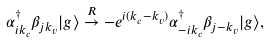<formula> <loc_0><loc_0><loc_500><loc_500>\alpha ^ { \dag } _ { i k _ { c } } \beta _ { j k _ { v } } | g \rangle \stackrel { R } { \to } - e ^ { i ( k _ { c } - k _ { v } ) } \alpha ^ { \dag } _ { - i k _ { c } } \beta _ { j - k _ { v } } | g \rangle ,</formula> 